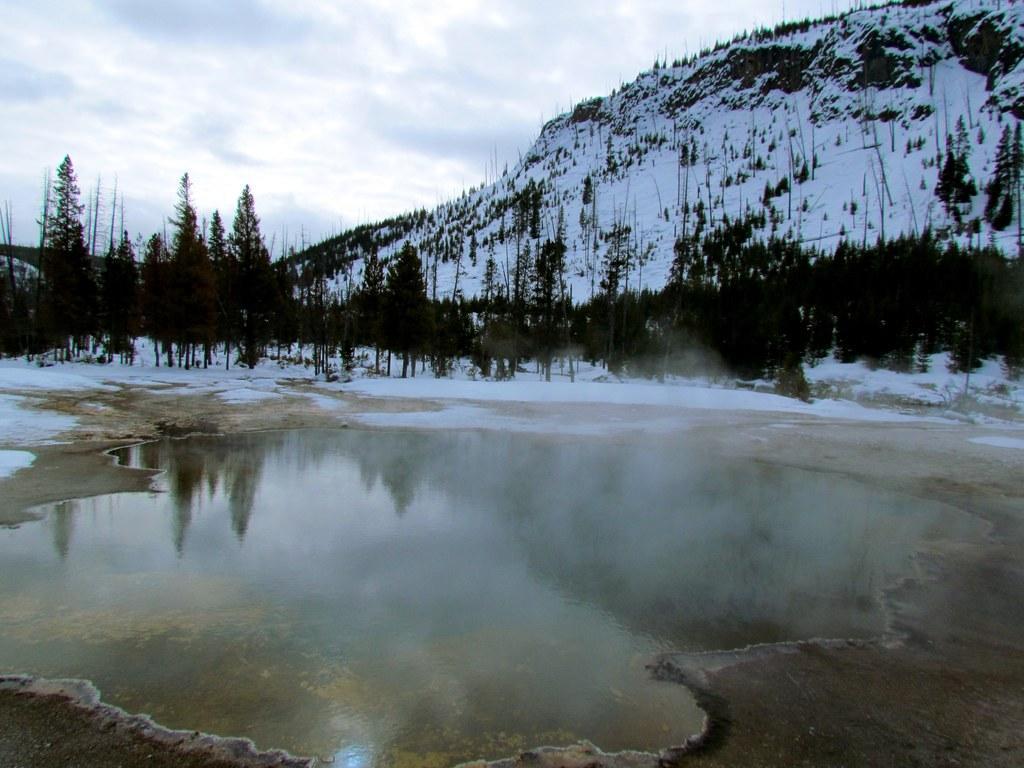How would you summarize this image in a sentence or two? In the center of the image there is water. In the background of the image there is a snow mountain and trees. 